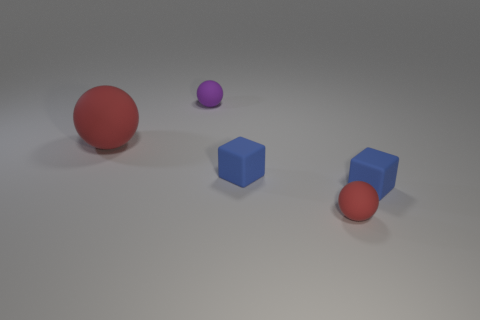What material is the sphere that is the same color as the large object?
Your answer should be very brief. Rubber. The other rubber thing that is the same color as the big matte thing is what size?
Offer a terse response. Small. Are there any things of the same color as the big matte ball?
Offer a very short reply. Yes. Is the number of small blue rubber things greater than the number of tiny red spheres?
Ensure brevity in your answer.  Yes. How many blue matte cubes are the same size as the purple rubber thing?
Your answer should be very brief. 2. What number of objects are either red spheres that are in front of the big red rubber object or tiny blue matte things?
Give a very brief answer. 3. Is the number of tiny blue objects less than the number of red metal cubes?
Give a very brief answer. No. Are there any blue blocks behind the tiny red ball?
Provide a succinct answer. Yes. Are there fewer blue objects that are behind the purple rubber ball than tiny blue cylinders?
Give a very brief answer. No. What is the tiny purple object made of?
Your answer should be compact. Rubber. 